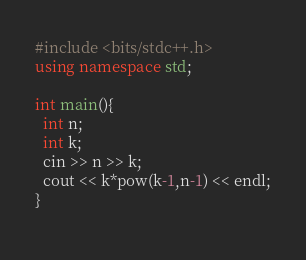<code> <loc_0><loc_0><loc_500><loc_500><_C++_>#include <bits/stdc++.h>
using namespace std;

int main(){
  int n;
  int k;
  cin >> n >> k;
  cout << k*pow(k-1,n-1) << endl;
}
    </code> 